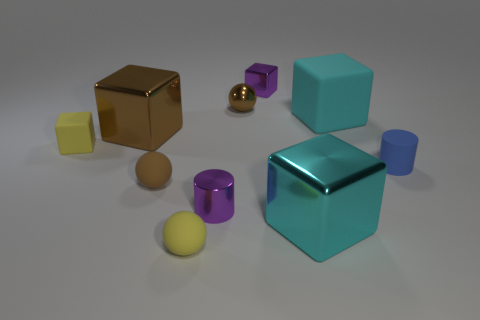Are there an equal number of brown shiny balls behind the purple cylinder and things behind the small blue cylinder?
Keep it short and to the point. No. What is the small brown object right of the small brown matte sphere made of?
Give a very brief answer. Metal. What number of objects are yellow objects in front of the yellow matte cube or small red blocks?
Provide a short and direct response. 1. How many other things are there of the same shape as the brown matte object?
Keep it short and to the point. 2. There is a object behind the metal ball; is its shape the same as the small blue rubber object?
Provide a short and direct response. No. There is a tiny blue rubber thing; are there any big cyan blocks in front of it?
Ensure brevity in your answer.  Yes. How many big objects are either cyan rubber cubes or cyan metal blocks?
Provide a succinct answer. 2. Are the yellow block and the blue cylinder made of the same material?
Offer a terse response. Yes. What is the size of the other ball that is the same color as the tiny metallic sphere?
Give a very brief answer. Small. Is there a metallic object of the same color as the small metal cube?
Give a very brief answer. Yes. 